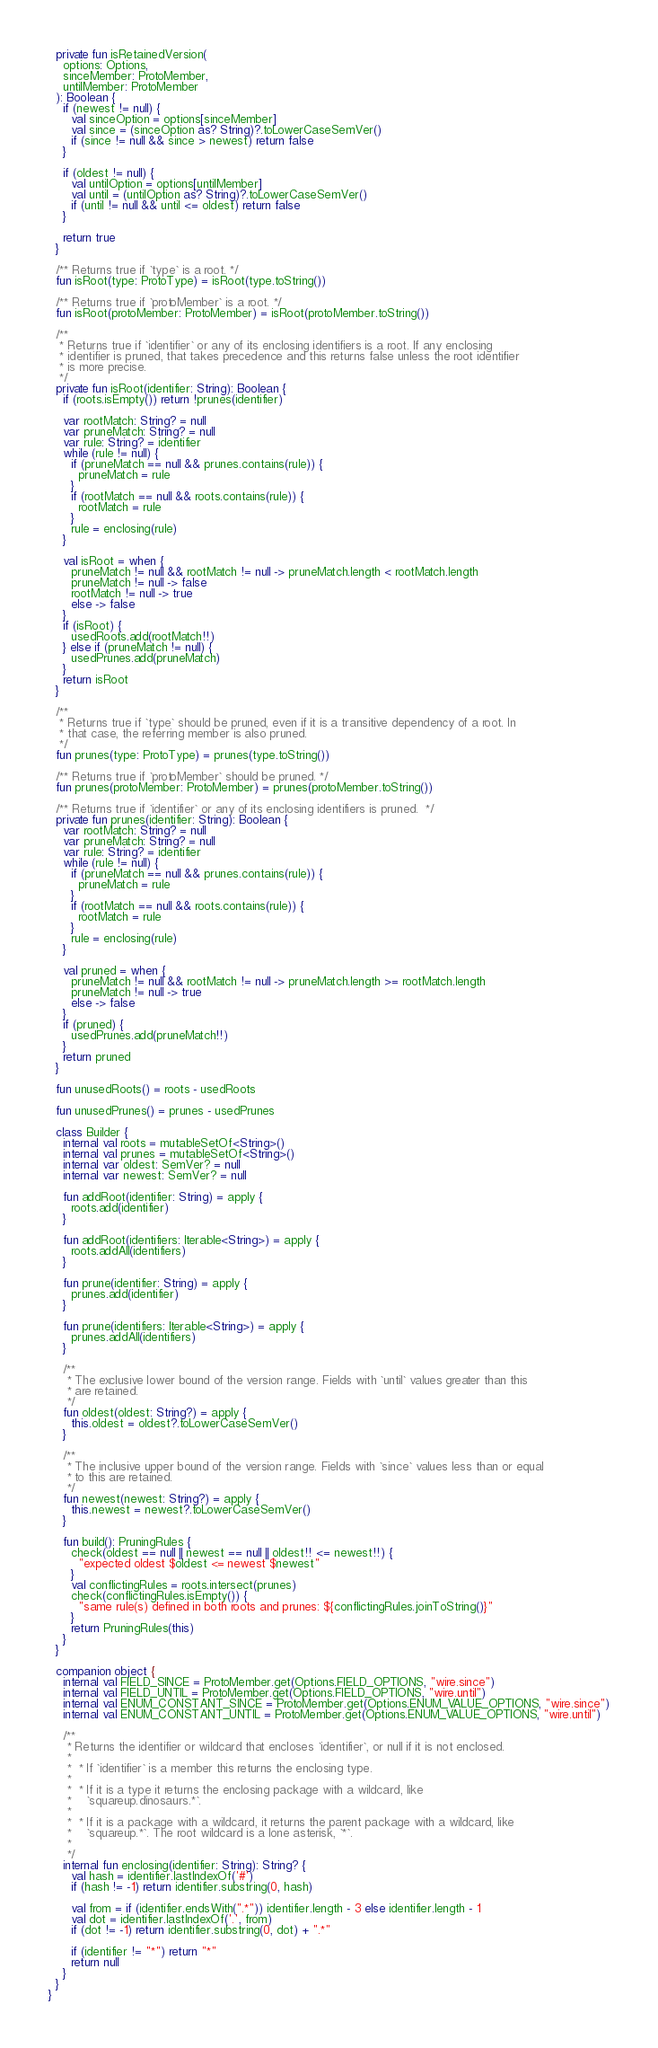<code> <loc_0><loc_0><loc_500><loc_500><_Kotlin_>
  private fun isRetainedVersion(
    options: Options,
    sinceMember: ProtoMember,
    untilMember: ProtoMember
  ): Boolean {
    if (newest != null) {
      val sinceOption = options[sinceMember]
      val since = (sinceOption as? String)?.toLowerCaseSemVer()
      if (since != null && since > newest) return false
    }

    if (oldest != null) {
      val untilOption = options[untilMember]
      val until = (untilOption as? String)?.toLowerCaseSemVer()
      if (until != null && until <= oldest) return false
    }

    return true
  }

  /** Returns true if `type` is a root. */
  fun isRoot(type: ProtoType) = isRoot(type.toString())

  /** Returns true if `protoMember` is a root. */
  fun isRoot(protoMember: ProtoMember) = isRoot(protoMember.toString())

  /**
   * Returns true if `identifier` or any of its enclosing identifiers is a root. If any enclosing
   * identifier is pruned, that takes precedence and this returns false unless the root identifier
   * is more precise.
   */
  private fun isRoot(identifier: String): Boolean {
    if (roots.isEmpty()) return !prunes(identifier)

    var rootMatch: String? = null
    var pruneMatch: String? = null
    var rule: String? = identifier
    while (rule != null) {
      if (pruneMatch == null && prunes.contains(rule)) {
        pruneMatch = rule
      }
      if (rootMatch == null && roots.contains(rule)) {
        rootMatch = rule
      }
      rule = enclosing(rule)
    }

    val isRoot = when {
      pruneMatch != null && rootMatch != null -> pruneMatch.length < rootMatch.length
      pruneMatch != null -> false
      rootMatch != null -> true
      else -> false
    }
    if (isRoot) {
      usedRoots.add(rootMatch!!)
    } else if (pruneMatch != null) {
      usedPrunes.add(pruneMatch)
    }
    return isRoot
  }

  /**
   * Returns true if `type` should be pruned, even if it is a transitive dependency of a root. In
   * that case, the referring member is also pruned.
   */
  fun prunes(type: ProtoType) = prunes(type.toString())

  /** Returns true if `protoMember` should be pruned. */
  fun prunes(protoMember: ProtoMember) = prunes(protoMember.toString())

  /** Returns true if `identifier` or any of its enclosing identifiers is pruned.  */
  private fun prunes(identifier: String): Boolean {
    var rootMatch: String? = null
    var pruneMatch: String? = null
    var rule: String? = identifier
    while (rule != null) {
      if (pruneMatch == null && prunes.contains(rule)) {
        pruneMatch = rule
      }
      if (rootMatch == null && roots.contains(rule)) {
        rootMatch = rule
      }
      rule = enclosing(rule)
    }

    val pruned = when {
      pruneMatch != null && rootMatch != null -> pruneMatch.length >= rootMatch.length
      pruneMatch != null -> true
      else -> false
    }
    if (pruned) {
      usedPrunes.add(pruneMatch!!)
    }
    return pruned
  }

  fun unusedRoots() = roots - usedRoots

  fun unusedPrunes() = prunes - usedPrunes

  class Builder {
    internal val roots = mutableSetOf<String>()
    internal val prunes = mutableSetOf<String>()
    internal var oldest: SemVer? = null
    internal var newest: SemVer? = null

    fun addRoot(identifier: String) = apply {
      roots.add(identifier)
    }

    fun addRoot(identifiers: Iterable<String>) = apply {
      roots.addAll(identifiers)
    }

    fun prune(identifier: String) = apply {
      prunes.add(identifier)
    }

    fun prune(identifiers: Iterable<String>) = apply {
      prunes.addAll(identifiers)
    }

    /**
     * The exclusive lower bound of the version range. Fields with `until` values greater than this
     * are retained.
     */
    fun oldest(oldest: String?) = apply {
      this.oldest = oldest?.toLowerCaseSemVer()
    }

    /**
     * The inclusive upper bound of the version range. Fields with `since` values less than or equal
     * to this are retained.
     */
    fun newest(newest: String?) = apply {
      this.newest = newest?.toLowerCaseSemVer()
    }

    fun build(): PruningRules {
      check(oldest == null || newest == null || oldest!! <= newest!!) {
        "expected oldest $oldest <= newest $newest"
      }
      val conflictingRules = roots.intersect(prunes)
      check(conflictingRules.isEmpty()) {
        "same rule(s) defined in both roots and prunes: ${conflictingRules.joinToString()}"
      }
      return PruningRules(this)
    }
  }

  companion object {
    internal val FIELD_SINCE = ProtoMember.get(Options.FIELD_OPTIONS, "wire.since")
    internal val FIELD_UNTIL = ProtoMember.get(Options.FIELD_OPTIONS, "wire.until")
    internal val ENUM_CONSTANT_SINCE = ProtoMember.get(Options.ENUM_VALUE_OPTIONS, "wire.since")
    internal val ENUM_CONSTANT_UNTIL = ProtoMember.get(Options.ENUM_VALUE_OPTIONS, "wire.until")

    /**
     * Returns the identifier or wildcard that encloses `identifier`, or null if it is not enclosed.
     *
     *  * If `identifier` is a member this returns the enclosing type.
     *
     *  * If it is a type it returns the enclosing package with a wildcard, like
     *    `squareup.dinosaurs.*`.
     *
     *  * If it is a package with a wildcard, it returns the parent package with a wildcard, like
     *    `squareup.*`. The root wildcard is a lone asterisk, `*`.
     *
     */
    internal fun enclosing(identifier: String): String? {
      val hash = identifier.lastIndexOf('#')
      if (hash != -1) return identifier.substring(0, hash)

      val from = if (identifier.endsWith(".*")) identifier.length - 3 else identifier.length - 1
      val dot = identifier.lastIndexOf('.', from)
      if (dot != -1) return identifier.substring(0, dot) + ".*"

      if (identifier != "*") return "*"
      return null
    }
  }
}
</code> 